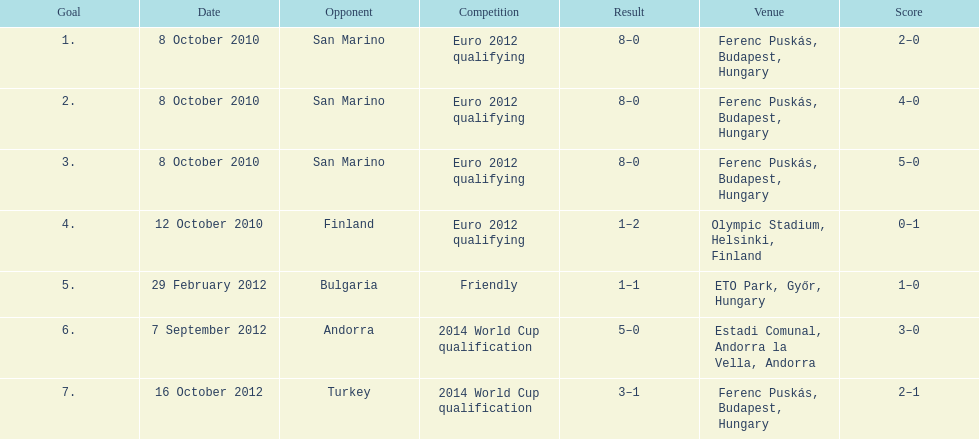In how many non-qualifying matches did he make a score? 1. 